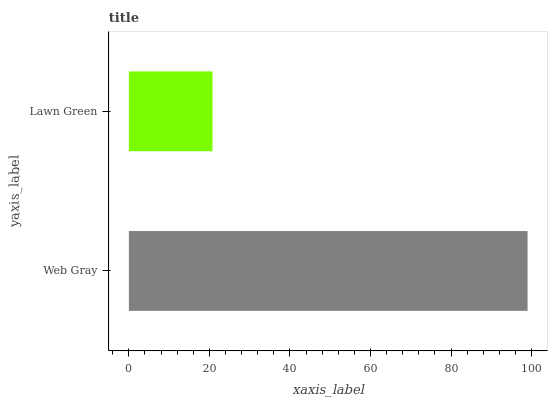Is Lawn Green the minimum?
Answer yes or no. Yes. Is Web Gray the maximum?
Answer yes or no. Yes. Is Lawn Green the maximum?
Answer yes or no. No. Is Web Gray greater than Lawn Green?
Answer yes or no. Yes. Is Lawn Green less than Web Gray?
Answer yes or no. Yes. Is Lawn Green greater than Web Gray?
Answer yes or no. No. Is Web Gray less than Lawn Green?
Answer yes or no. No. Is Web Gray the high median?
Answer yes or no. Yes. Is Lawn Green the low median?
Answer yes or no. Yes. Is Lawn Green the high median?
Answer yes or no. No. Is Web Gray the low median?
Answer yes or no. No. 